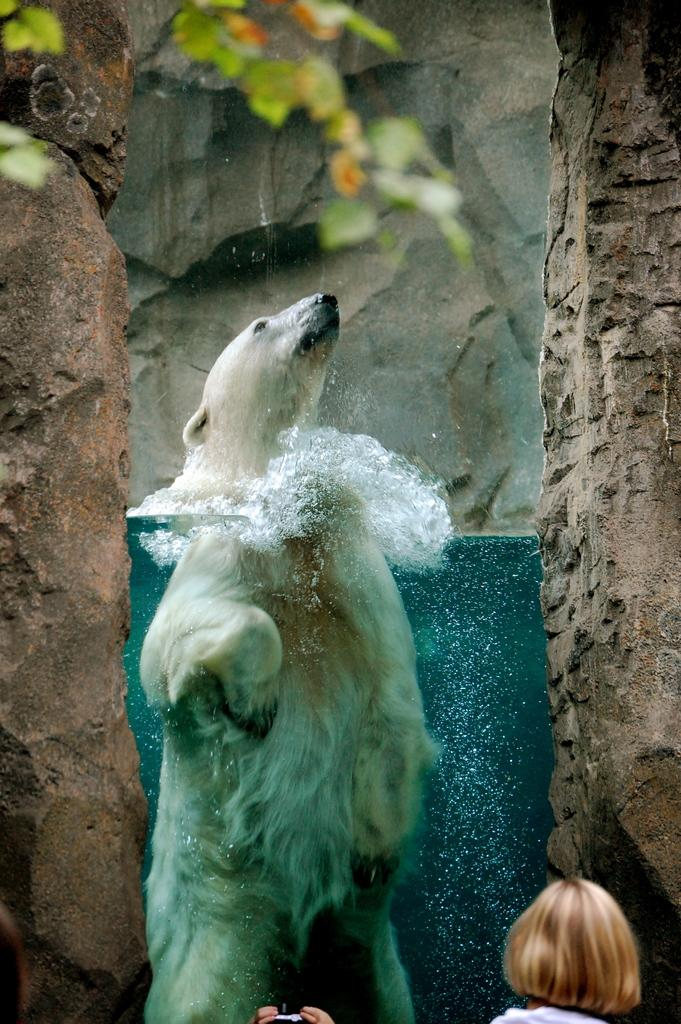What type of animal can be seen in the image? There is an animal in the image, but its specific type cannot be determined from the provided facts. What is the primary element in the image? There is water in the image. What other objects or features can be seen in the image? There are rocks and leaves in the image. Is there any indication of human presence in the image? Yes, a person is partially visible at the bottom of the image. What type of stem can be seen growing from the mouth of the animal in the image? There is no stem or mouth visible in the image, as it features an animal, water, rocks, leaves, and a partially visible person. 